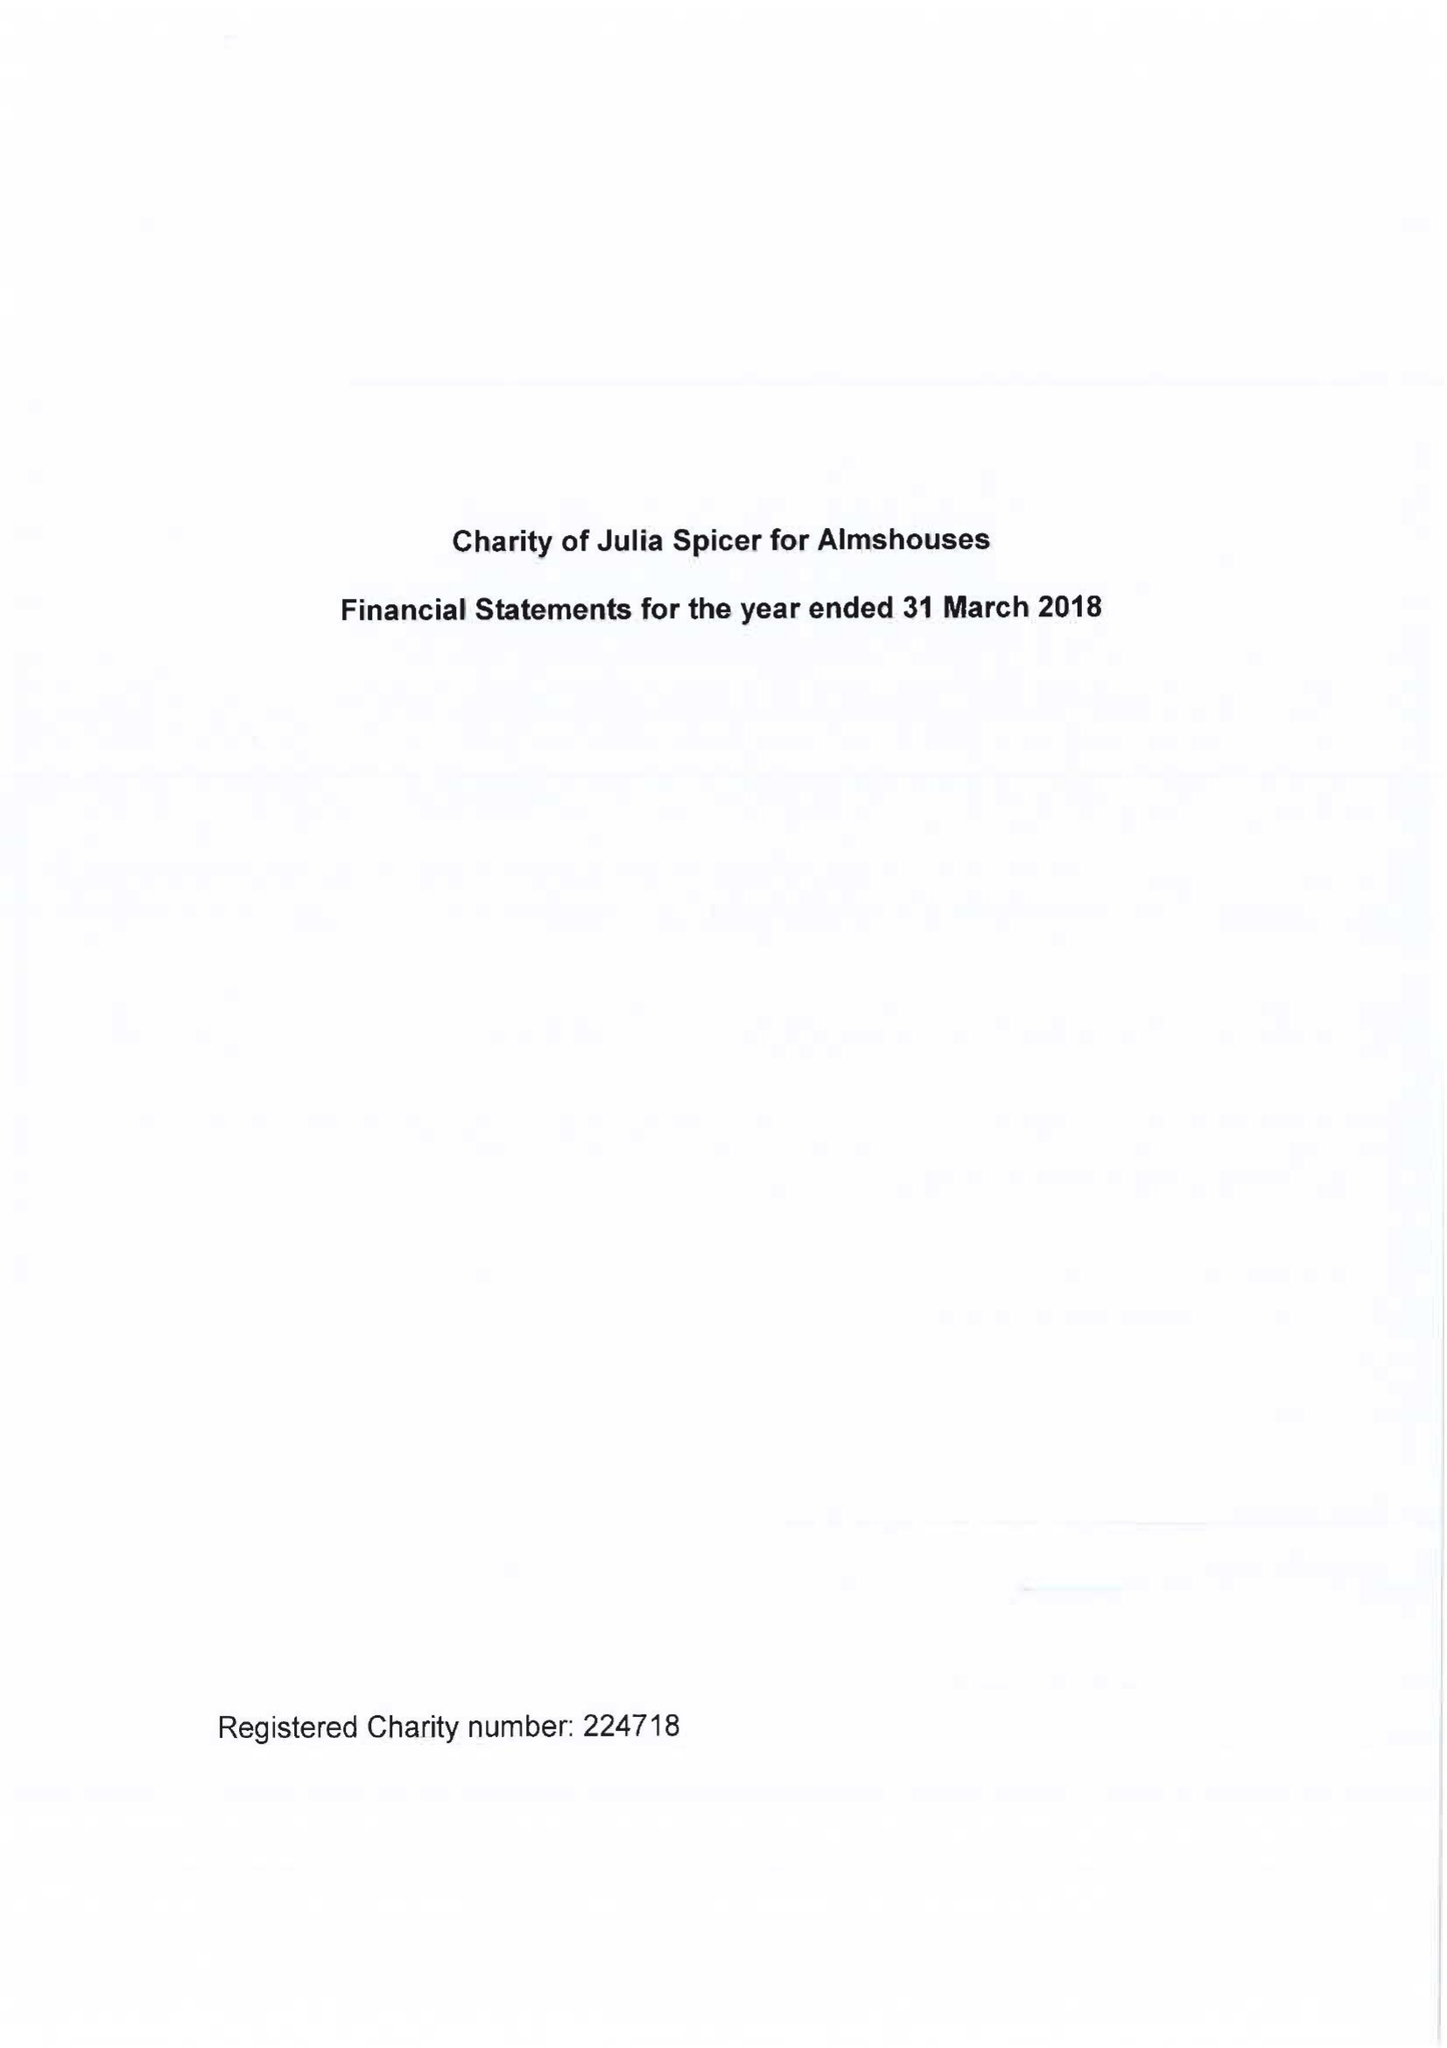What is the value for the report_date?
Answer the question using a single word or phrase. 2018-03-31 